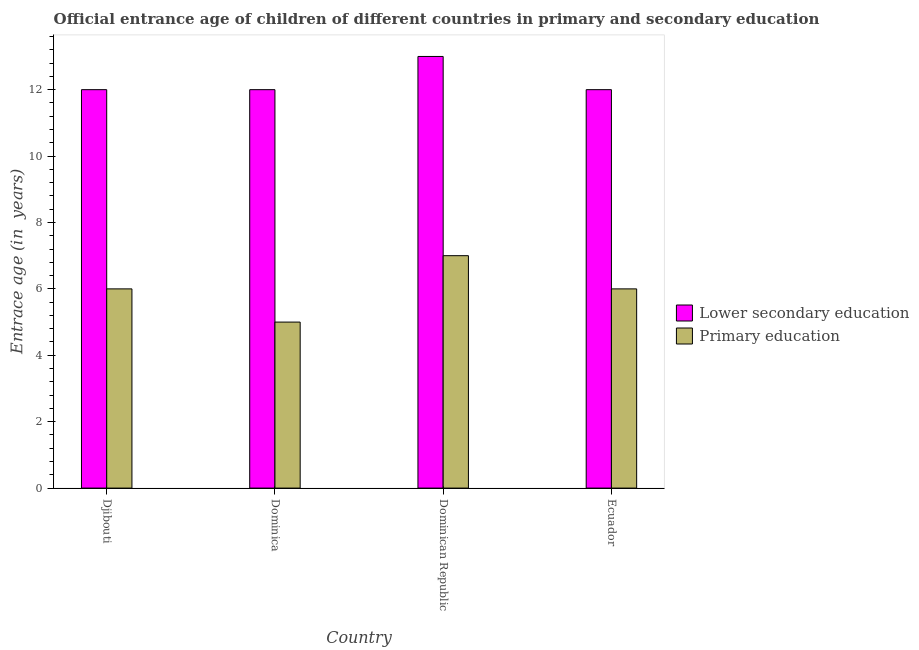How many bars are there on the 1st tick from the left?
Provide a succinct answer. 2. How many bars are there on the 2nd tick from the right?
Your answer should be very brief. 2. What is the label of the 3rd group of bars from the left?
Keep it short and to the point. Dominican Republic. In how many cases, is the number of bars for a given country not equal to the number of legend labels?
Give a very brief answer. 0. What is the entrance age of chiildren in primary education in Dominican Republic?
Keep it short and to the point. 7. Across all countries, what is the maximum entrance age of chiildren in primary education?
Offer a very short reply. 7. Across all countries, what is the minimum entrance age of children in lower secondary education?
Ensure brevity in your answer.  12. In which country was the entrance age of chiildren in primary education maximum?
Provide a short and direct response. Dominican Republic. In which country was the entrance age of children in lower secondary education minimum?
Provide a succinct answer. Djibouti. What is the total entrance age of chiildren in primary education in the graph?
Your response must be concise. 24. What is the difference between the entrance age of chiildren in primary education in Dominican Republic and that in Ecuador?
Your answer should be very brief. 1. What is the difference between the entrance age of children in lower secondary education in Dominica and the entrance age of chiildren in primary education in Dominican Republic?
Make the answer very short. 5. What is the difference between the entrance age of children in lower secondary education and entrance age of chiildren in primary education in Dominican Republic?
Your answer should be very brief. 6. In how many countries, is the entrance age of chiildren in primary education greater than 2.8 years?
Offer a terse response. 4. What is the difference between the highest and the second highest entrance age of chiildren in primary education?
Offer a very short reply. 1. What is the difference between the highest and the lowest entrance age of chiildren in primary education?
Offer a terse response. 2. Is the sum of the entrance age of chiildren in primary education in Djibouti and Dominica greater than the maximum entrance age of children in lower secondary education across all countries?
Make the answer very short. No. What does the 1st bar from the left in Djibouti represents?
Offer a very short reply. Lower secondary education. What does the 1st bar from the right in Ecuador represents?
Your response must be concise. Primary education. Are all the bars in the graph horizontal?
Your answer should be compact. No. What is the difference between two consecutive major ticks on the Y-axis?
Your answer should be compact. 2. Are the values on the major ticks of Y-axis written in scientific E-notation?
Ensure brevity in your answer.  No. How many legend labels are there?
Provide a succinct answer. 2. How are the legend labels stacked?
Keep it short and to the point. Vertical. What is the title of the graph?
Ensure brevity in your answer.  Official entrance age of children of different countries in primary and secondary education. Does "Girls" appear as one of the legend labels in the graph?
Your response must be concise. No. What is the label or title of the X-axis?
Provide a succinct answer. Country. What is the label or title of the Y-axis?
Your answer should be compact. Entrace age (in  years). What is the Entrace age (in  years) in Lower secondary education in Djibouti?
Keep it short and to the point. 12. What is the Entrace age (in  years) of Primary education in Djibouti?
Offer a very short reply. 6. What is the Entrace age (in  years) in Lower secondary education in Dominican Republic?
Keep it short and to the point. 13. What is the Entrace age (in  years) in Primary education in Dominican Republic?
Offer a terse response. 7. What is the Entrace age (in  years) of Lower secondary education in Ecuador?
Ensure brevity in your answer.  12. What is the Entrace age (in  years) of Primary education in Ecuador?
Ensure brevity in your answer.  6. Across all countries, what is the minimum Entrace age (in  years) of Lower secondary education?
Offer a very short reply. 12. Across all countries, what is the minimum Entrace age (in  years) in Primary education?
Your response must be concise. 5. What is the total Entrace age (in  years) in Primary education in the graph?
Make the answer very short. 24. What is the difference between the Entrace age (in  years) in Primary education in Djibouti and that in Dominican Republic?
Offer a terse response. -1. What is the difference between the Entrace age (in  years) in Lower secondary education in Djibouti and that in Ecuador?
Offer a very short reply. 0. What is the difference between the Entrace age (in  years) of Lower secondary education in Dominica and that in Ecuador?
Make the answer very short. 0. What is the difference between the Entrace age (in  years) of Lower secondary education in Djibouti and the Entrace age (in  years) of Primary education in Ecuador?
Give a very brief answer. 6. What is the difference between the Entrace age (in  years) in Lower secondary education in Dominica and the Entrace age (in  years) in Primary education in Dominican Republic?
Your response must be concise. 5. What is the difference between the Entrace age (in  years) of Lower secondary education in Dominica and the Entrace age (in  years) of Primary education in Ecuador?
Make the answer very short. 6. What is the average Entrace age (in  years) of Lower secondary education per country?
Offer a very short reply. 12.25. What is the difference between the Entrace age (in  years) of Lower secondary education and Entrace age (in  years) of Primary education in Dominica?
Provide a succinct answer. 7. What is the difference between the Entrace age (in  years) of Lower secondary education and Entrace age (in  years) of Primary education in Dominican Republic?
Your response must be concise. 6. What is the difference between the Entrace age (in  years) of Lower secondary education and Entrace age (in  years) of Primary education in Ecuador?
Provide a succinct answer. 6. What is the ratio of the Entrace age (in  years) in Primary education in Djibouti to that in Dominica?
Your answer should be very brief. 1.2. What is the ratio of the Entrace age (in  years) of Lower secondary education in Djibouti to that in Dominican Republic?
Provide a short and direct response. 0.92. What is the ratio of the Entrace age (in  years) in Primary education in Djibouti to that in Dominican Republic?
Your answer should be compact. 0.86. What is the ratio of the Entrace age (in  years) in Primary education in Djibouti to that in Ecuador?
Offer a very short reply. 1. What is the ratio of the Entrace age (in  years) in Lower secondary education in Dominica to that in Dominican Republic?
Ensure brevity in your answer.  0.92. What is the ratio of the Entrace age (in  years) in Lower secondary education in Dominica to that in Ecuador?
Offer a very short reply. 1. What is the ratio of the Entrace age (in  years) of Lower secondary education in Dominican Republic to that in Ecuador?
Provide a short and direct response. 1.08. What is the difference between the highest and the lowest Entrace age (in  years) of Lower secondary education?
Your answer should be compact. 1. What is the difference between the highest and the lowest Entrace age (in  years) of Primary education?
Offer a very short reply. 2. 